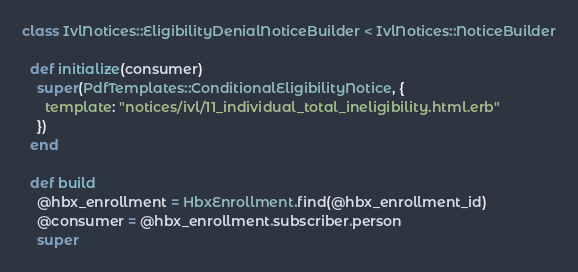Convert code to text. <code><loc_0><loc_0><loc_500><loc_500><_Ruby_>class IvlNotices::EligibilityDenialNoticeBuilder < IvlNotices::NoticeBuilder

  def initialize(consumer)
    super(PdfTemplates::ConditionalEligibilityNotice, {
      template: "notices/ivl/11_individual_total_ineligibility.html.erb"
    })
  end

  def build
    @hbx_enrollment = HbxEnrollment.find(@hbx_enrollment_id)
    @consumer = @hbx_enrollment.subscriber.person
    super</code> 